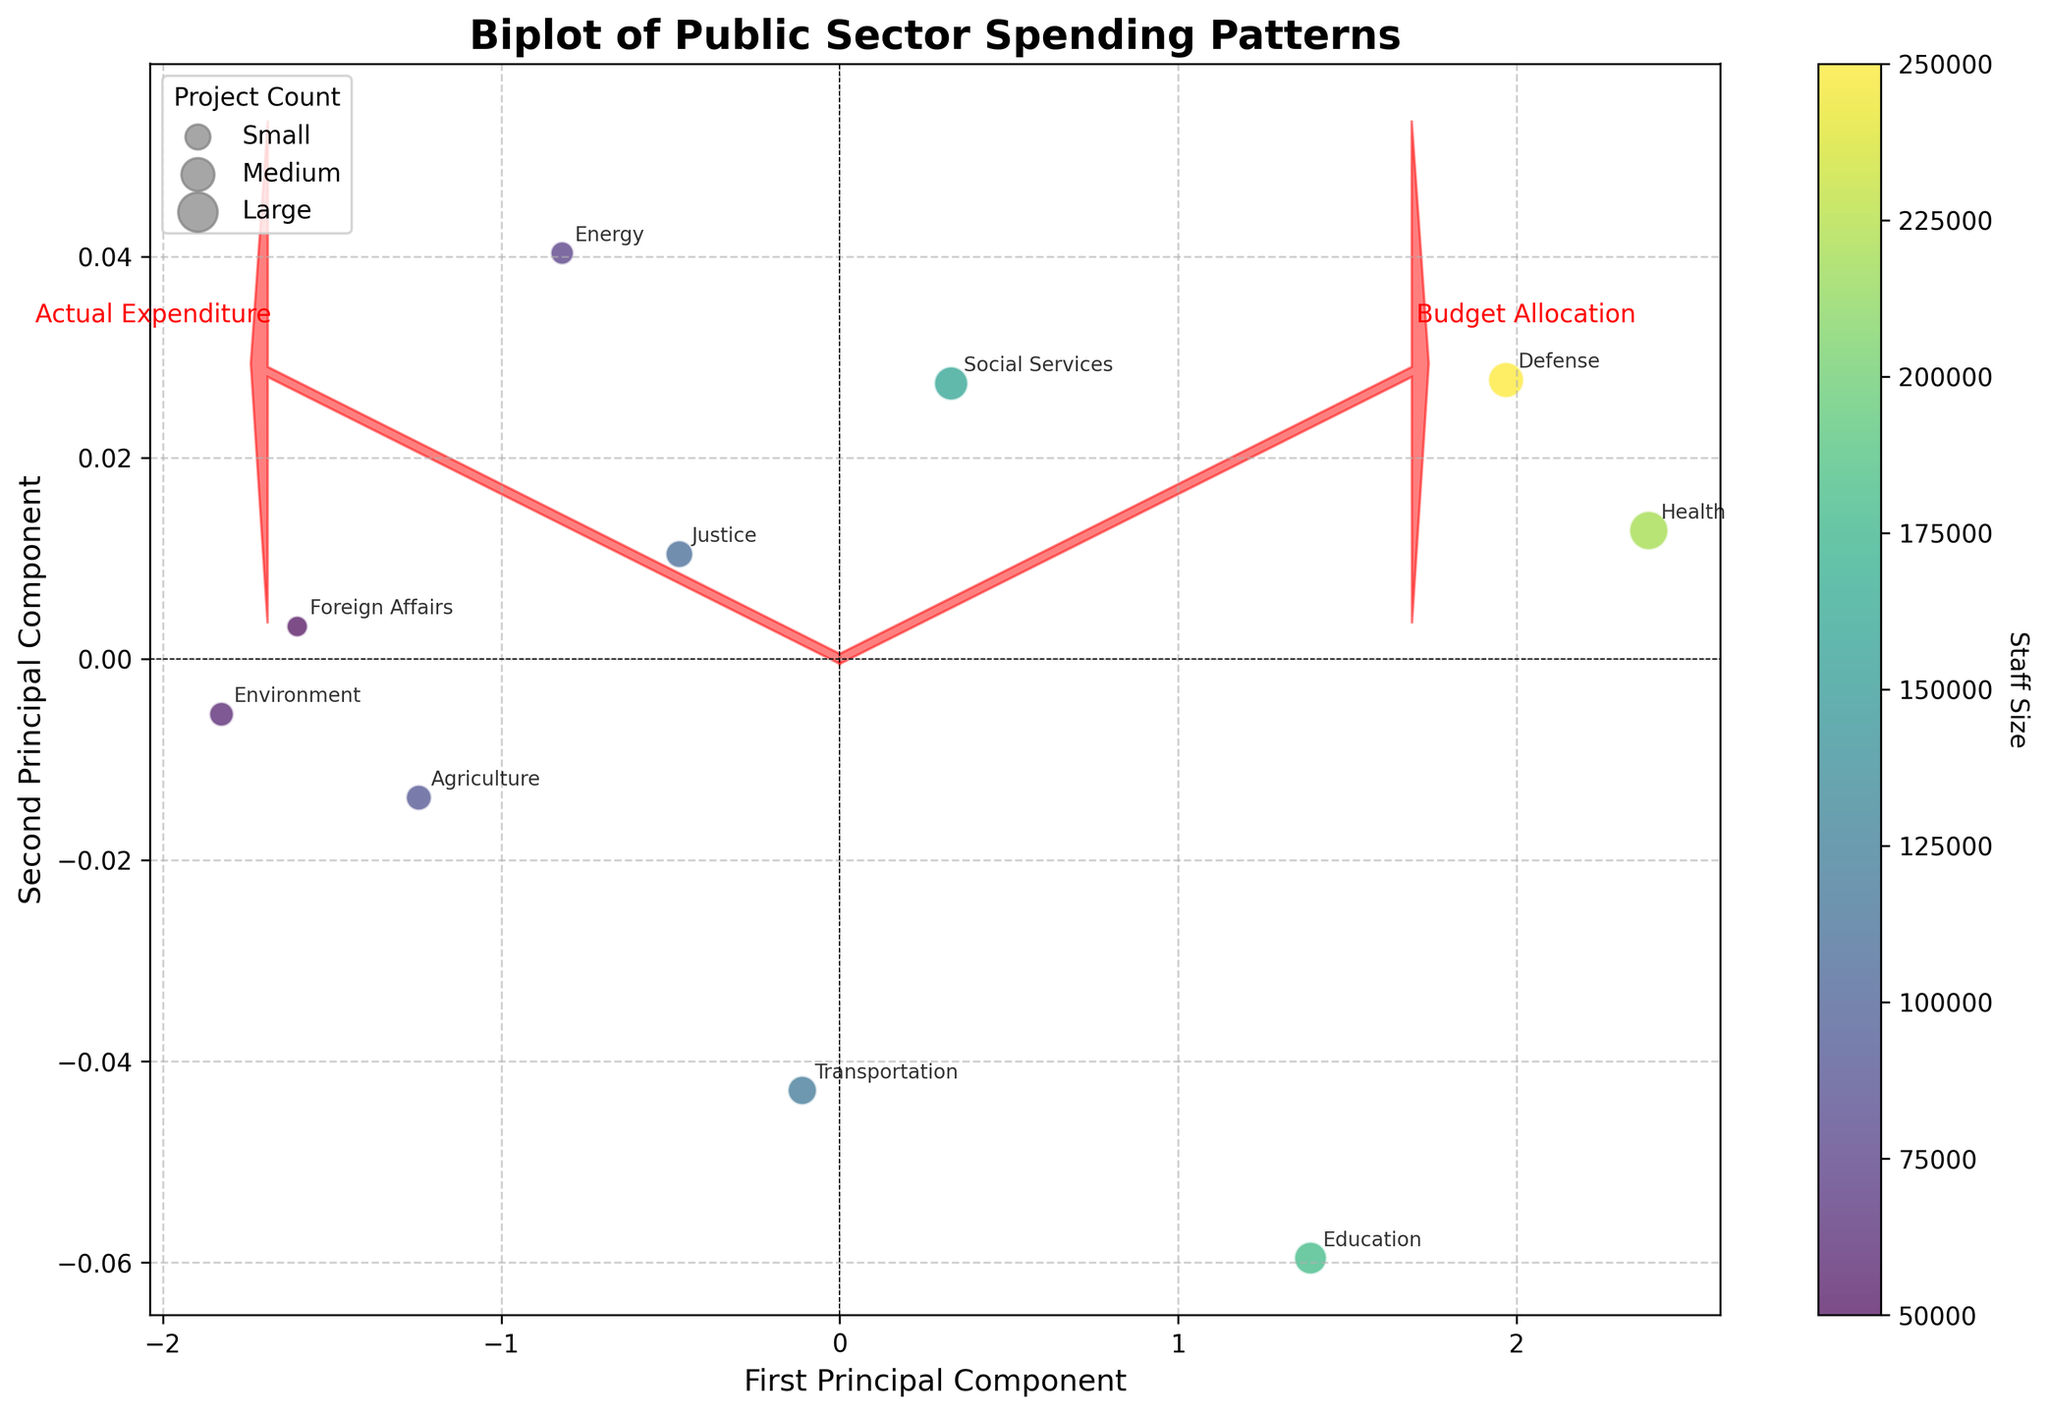What is the title of the plot? The title of the plot is typically found at the top of the figure. In this case, it is described in the provided code.
Answer: Biplot of Public Sector Spending Patterns How is the ‘Health’ department positioned relative to the first and second principal components? By locating the 'Health' label in the plot, we can determine its coordinates concerning the principal components. It is plotted slightly above the horizontal midline and to the left of the vertical midline.
Answer: Above and to the left of the midpoint Which department has the highest budget allocation and how is it represented in the plot? The department with the highest budget allocation is listed in the data, which is 'Health'. In the plot, the high budget allocation should correlate with a pronounced vector in the PCA direction.
Answer: Health, represented as a larger data point Are there any departments where the actual expenditure exceeds the budget allocation? Departments where the actual expenditure exceeds the budget allocation can be identified by looking at the vectors or offsets on the biplot. The vectors would show the direction of the overspending.
Answer: Yes, for example, 'Health' and 'Social Services' Which vector represents the 'Budget Allocation' and what does it indicate about the distribution of the departments? Arrows in the plot represent the variables' contribution to the principal components. The 'Budget Allocation' vector shows the distribution direction and pattern of the budget allocations, and its vector direction aligns where higher allocations cluster.
Answer: The red arrow pointing towards higher PC1 values How do 'Education' and 'Transportation' compare in terms of actual expenditure? By comparing the placement of the 'Education' and 'Transportation' labels relative to the 'Actual Expenditure' axis, we can infer their expenditure differences.
Answer: Education has a slightly higher expenditure Which department has the smallest project count and how is it represented in the plot? The smallest project count is represented by the smallest data point among the scatter points. In the data, 'Foreign Affairs' has the smallest project count.
Answer: Foreign Affairs, represented by a small dot How is the staff size visually represented in the plot? The color gradient of the scatter points indicates staff size, determined by the color bar on the side of the plot. Darker colors represent larger staff sizes.
Answer: By the color of the scatter points Which data point falls closest to the origin and what could this imply? Observing the data points closest to (0, 0) on the plot indicates near-average values for both the principal components. It suggests moderate budget and expenditure values without extreme deviations.
Answer: Agriculture What can you infer about departments with data points far from the origin in the biplot? Data points farthest from the origin indicate significant deviation in either budget allocation or actual expenditure from the mean. These departments have distinctive spending patterns.
Answer: Significant deviation in budget or expenditure 